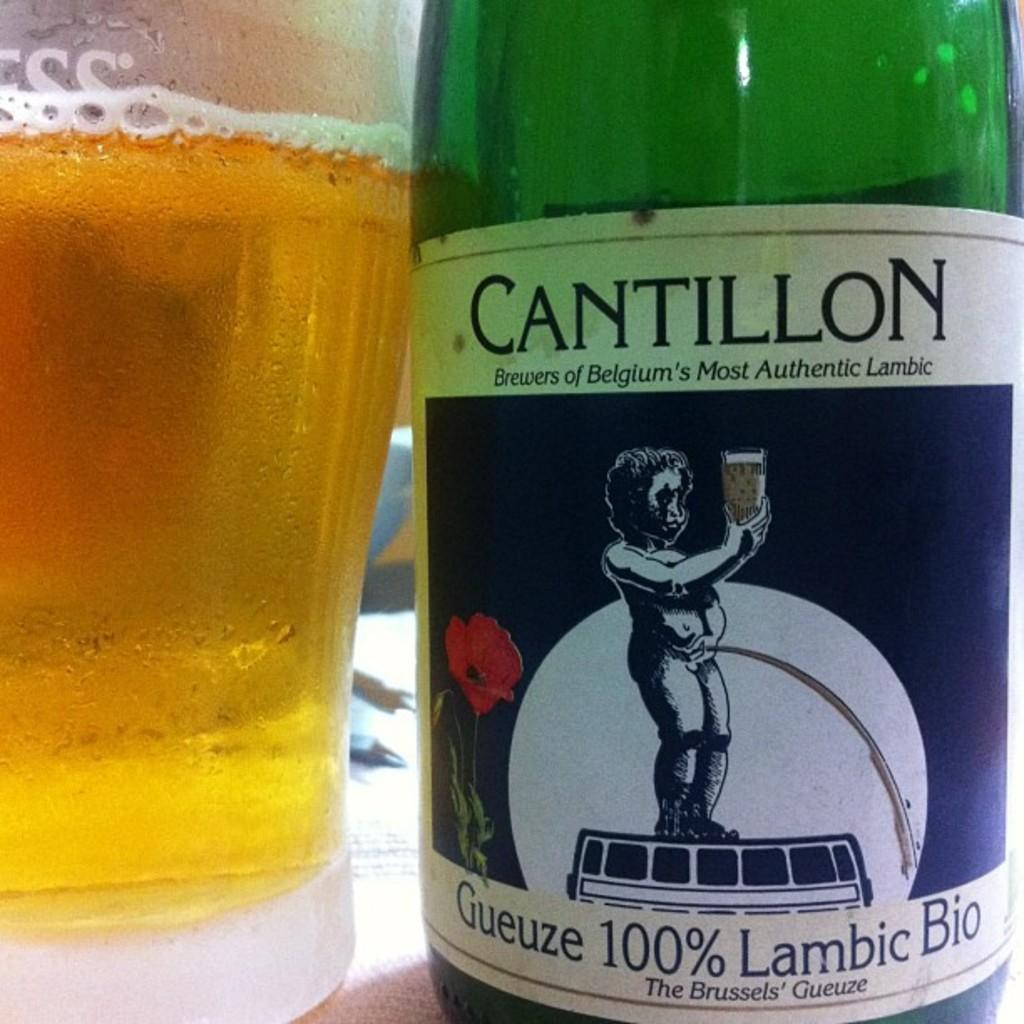<image>
Give a short and clear explanation of the subsequent image. A Cantillon brand beer bottle sits next to a full beer glass. 